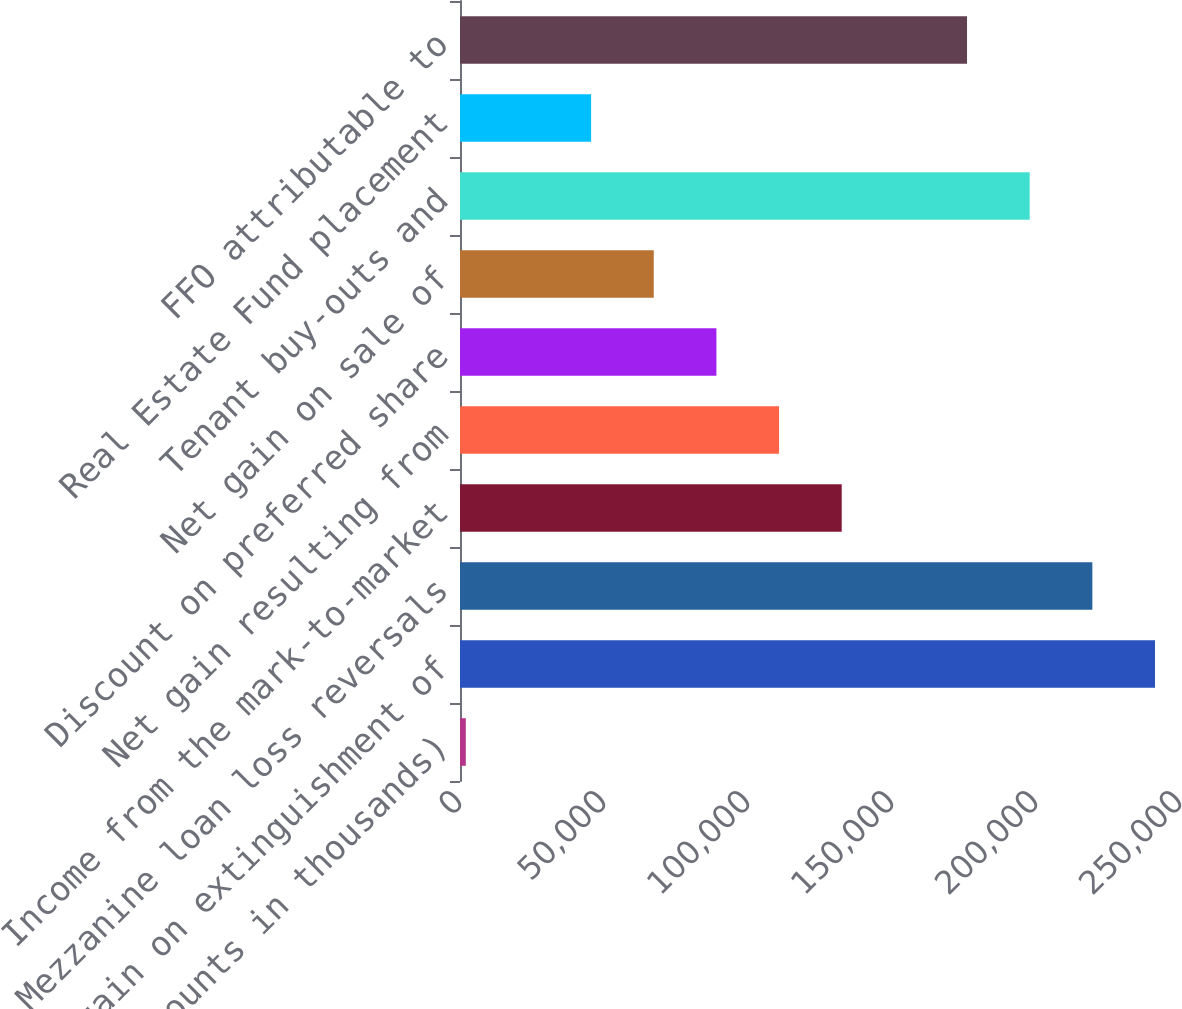Convert chart to OTSL. <chart><loc_0><loc_0><loc_500><loc_500><bar_chart><fcel>(Amounts in thousands)<fcel>Net gain on extinguishment of<fcel>Mezzanine loan loss reversals<fcel>Income from the mark-to-market<fcel>Net gain resulting from<fcel>Discount on preferred share<fcel>Net gain on sale of<fcel>Tenant buy-outs and<fcel>Real Estate Fund placement<fcel>FFO attributable to<nl><fcel>2011<fcel>241317<fcel>219562<fcel>132542<fcel>110786<fcel>89031.4<fcel>67276.3<fcel>197807<fcel>45521.2<fcel>176052<nl></chart> 